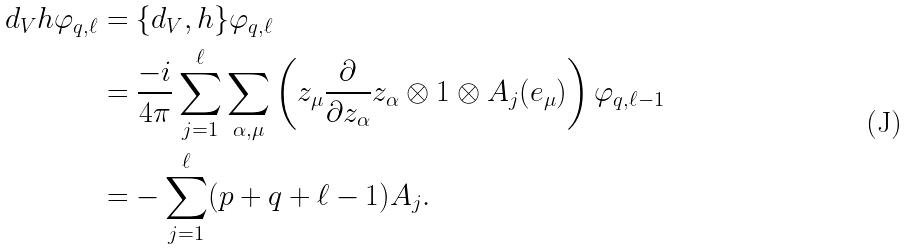<formula> <loc_0><loc_0><loc_500><loc_500>d _ { V } h \varphi _ { q , \ell } & = \{ d _ { V } , h \} \varphi _ { q , \ell } \\ & = \frac { - i } { 4 \pi } \sum _ { j = 1 } ^ { \ell } \sum _ { \alpha , \mu } \left ( z _ { \mu } \frac { \partial } { \partial z _ { \alpha } } z _ { \alpha } \otimes 1 \otimes A _ { j } ( e _ { \mu } ) \right ) \varphi _ { q , \ell - 1 } \\ & = - \sum _ { j = 1 } ^ { \ell } ( p + q + \ell - 1 ) A _ { j } .</formula> 